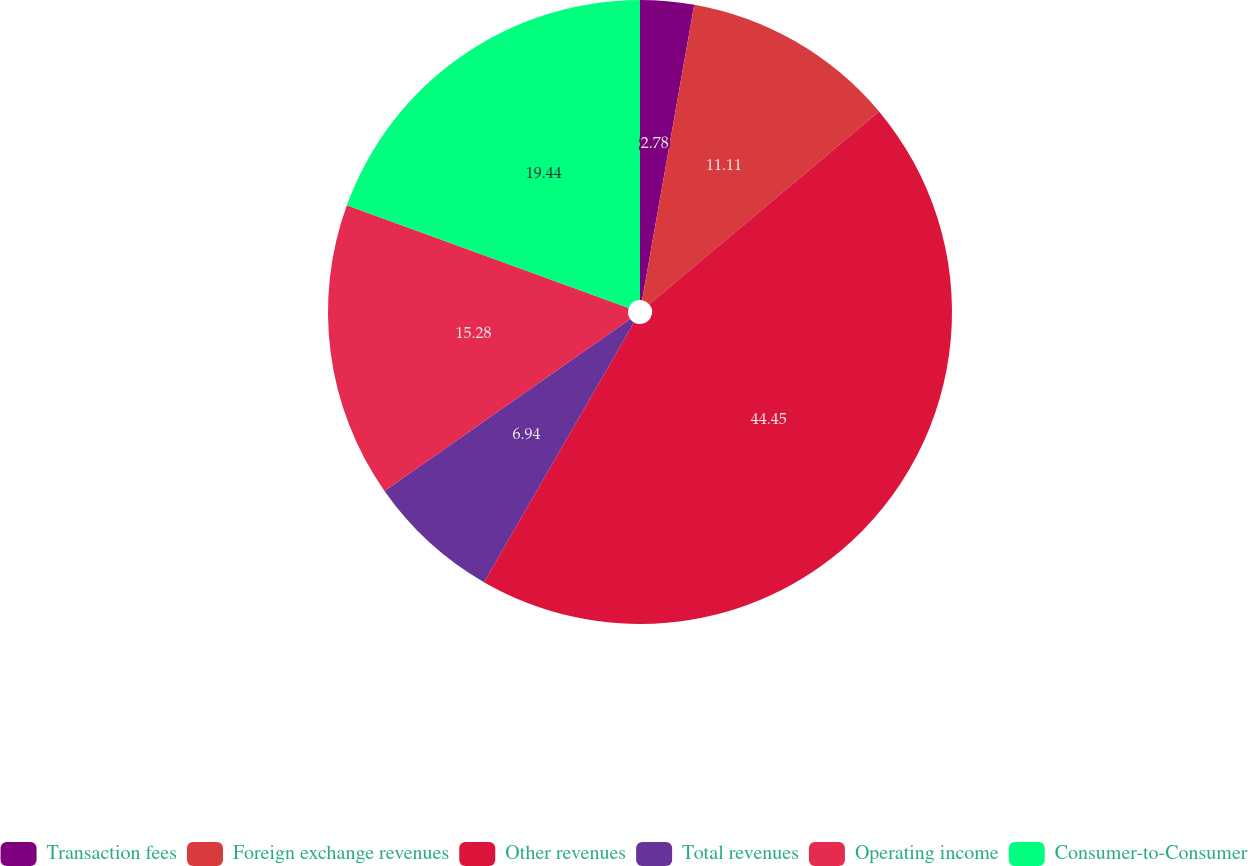Convert chart to OTSL. <chart><loc_0><loc_0><loc_500><loc_500><pie_chart><fcel>Transaction fees<fcel>Foreign exchange revenues<fcel>Other revenues<fcel>Total revenues<fcel>Operating income<fcel>Consumer-to-Consumer<nl><fcel>2.78%<fcel>11.11%<fcel>44.44%<fcel>6.94%<fcel>15.28%<fcel>19.44%<nl></chart> 